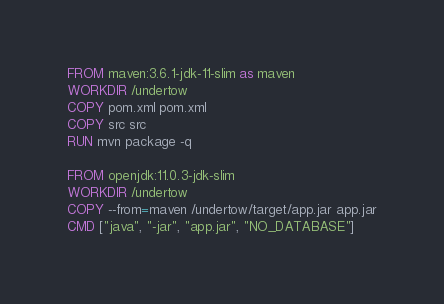Convert code to text. <code><loc_0><loc_0><loc_500><loc_500><_Dockerfile_>FROM maven:3.6.1-jdk-11-slim as maven
WORKDIR /undertow
COPY pom.xml pom.xml
COPY src src
RUN mvn package -q

FROM openjdk:11.0.3-jdk-slim
WORKDIR /undertow
COPY --from=maven /undertow/target/app.jar app.jar
CMD ["java", "-jar", "app.jar", "NO_DATABASE"]
</code> 